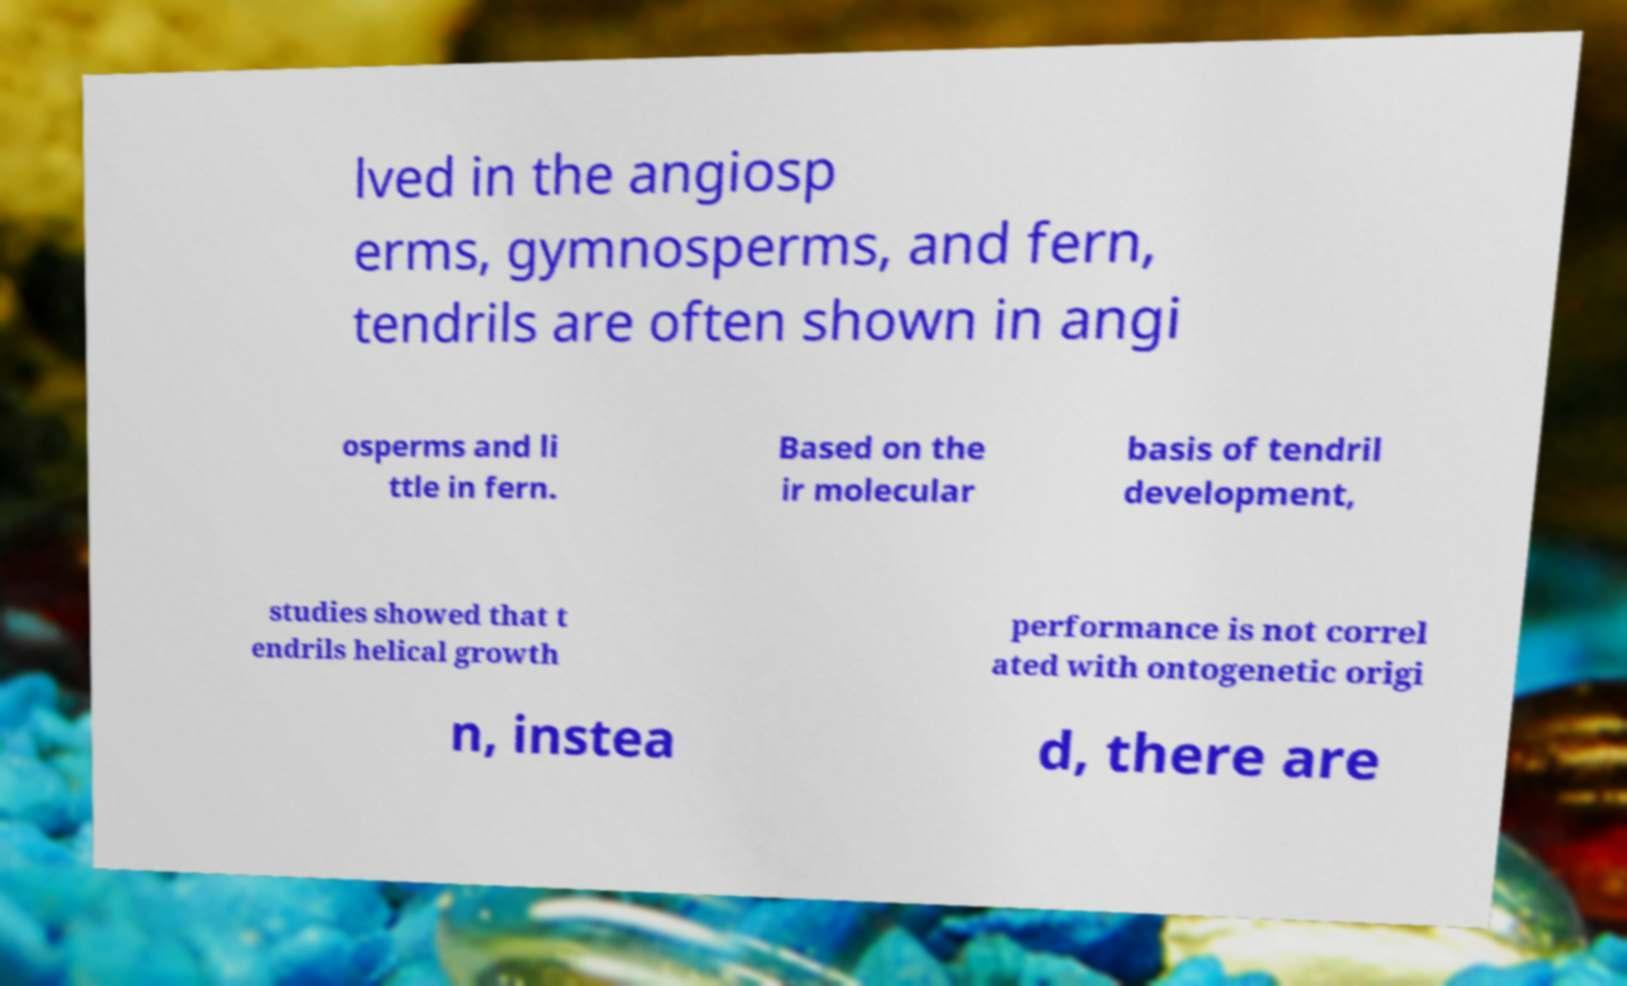There's text embedded in this image that I need extracted. Can you transcribe it verbatim? lved in the angiosp erms, gymnosperms, and fern, tendrils are often shown in angi osperms and li ttle in fern. Based on the ir molecular basis of tendril development, studies showed that t endrils helical growth performance is not correl ated with ontogenetic origi n, instea d, there are 